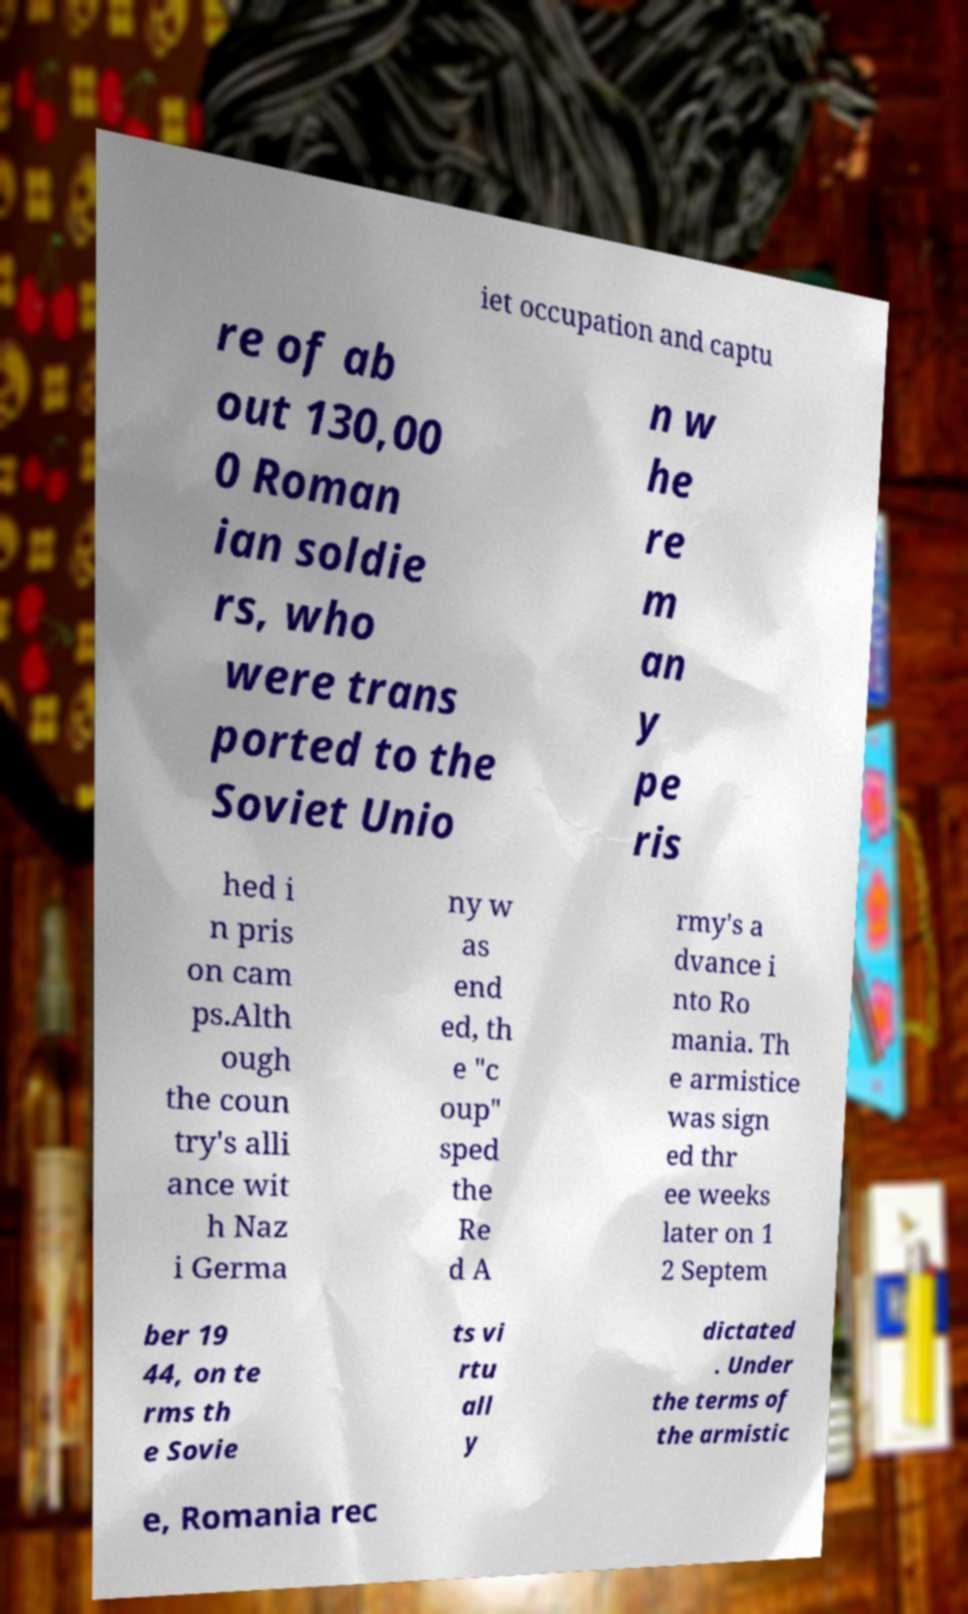Can you accurately transcribe the text from the provided image for me? iet occupation and captu re of ab out 130,00 0 Roman ian soldie rs, who were trans ported to the Soviet Unio n w he re m an y pe ris hed i n pris on cam ps.Alth ough the coun try's alli ance wit h Naz i Germa ny w as end ed, th e "c oup" sped the Re d A rmy's a dvance i nto Ro mania. Th e armistice was sign ed thr ee weeks later on 1 2 Septem ber 19 44, on te rms th e Sovie ts vi rtu all y dictated . Under the terms of the armistic e, Romania rec 